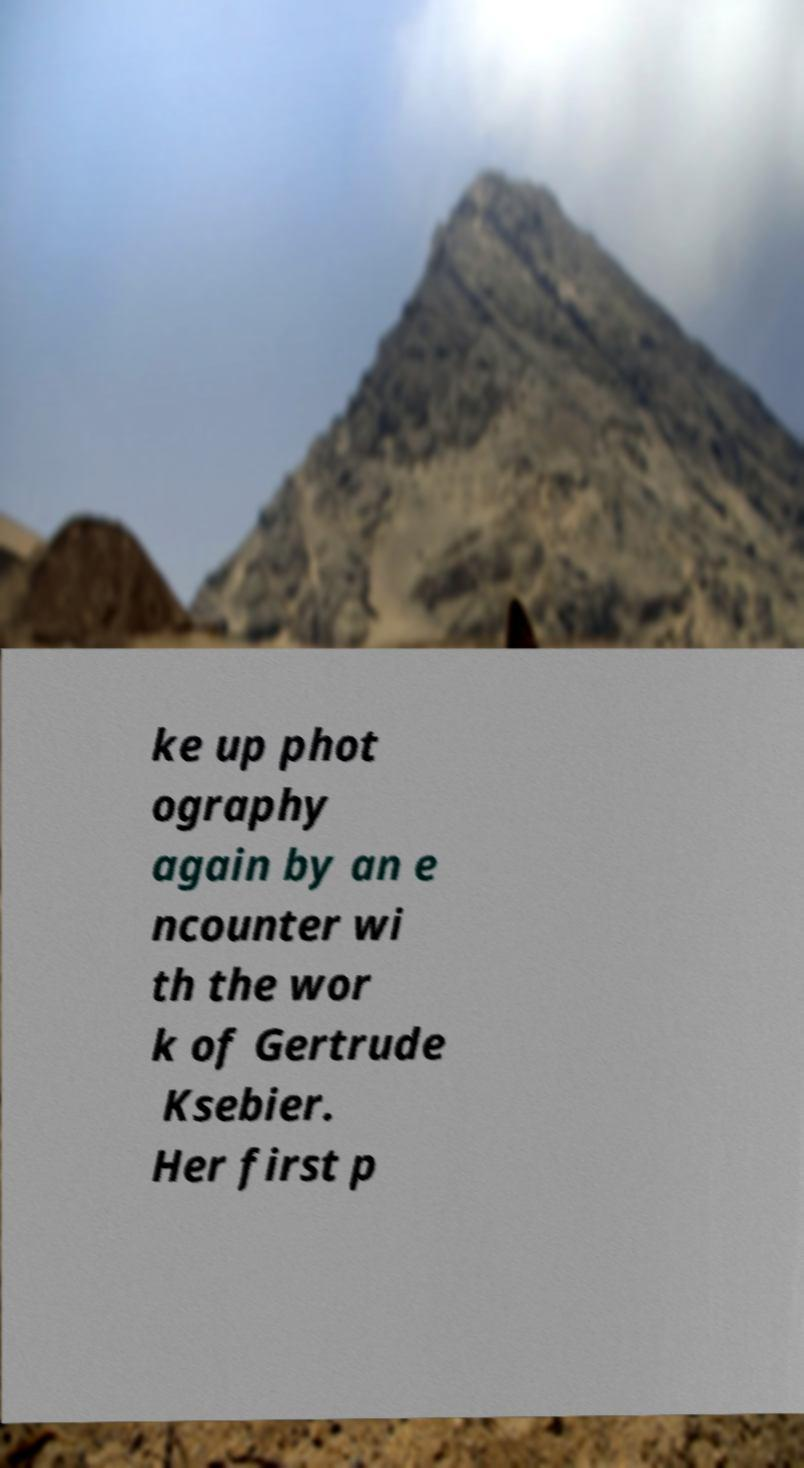Can you read and provide the text displayed in the image?This photo seems to have some interesting text. Can you extract and type it out for me? ke up phot ography again by an e ncounter wi th the wor k of Gertrude Ksebier. Her first p 